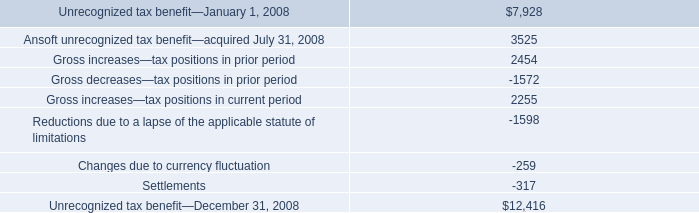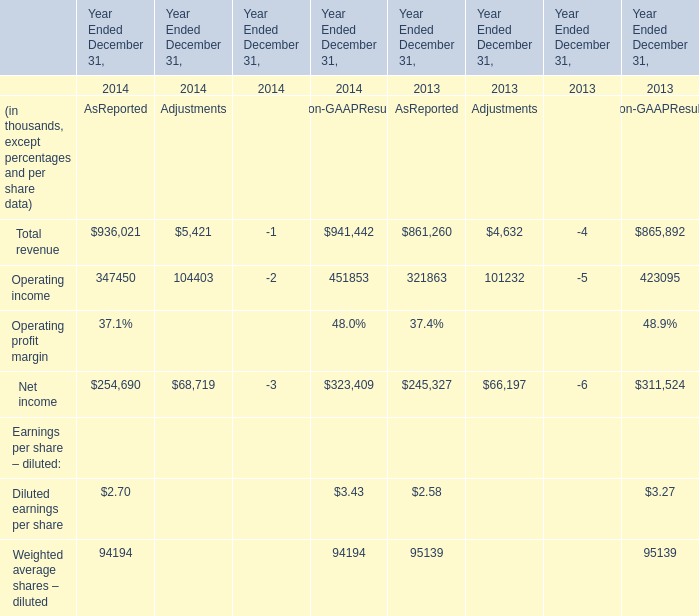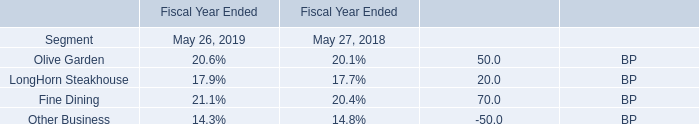what was the average expenses related to the company 2019s retirement programs from 2006 to 2008 in millions 
Computations: (((3.7 + 4.7) + 4.1) / 3)
Answer: 4.16667. 